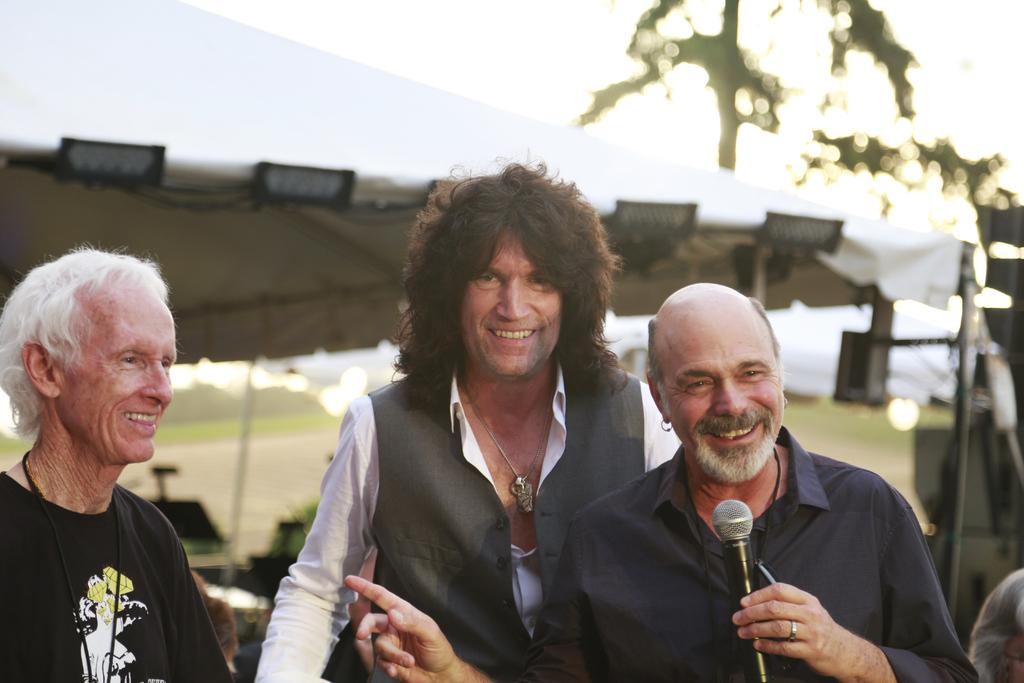How many people are in the image? There are three people in the image. What are the people doing in the image? The people are standing. Can you describe the man in the image? The man is holding a mic. What can be said about the background of the image? The background of the image is blurry. What type of shelf can be seen in the image? There is no shelf present in the image. What observation can be made about the people's flight in the image? There is no flight or indication of flying in the image; the people are standing. 